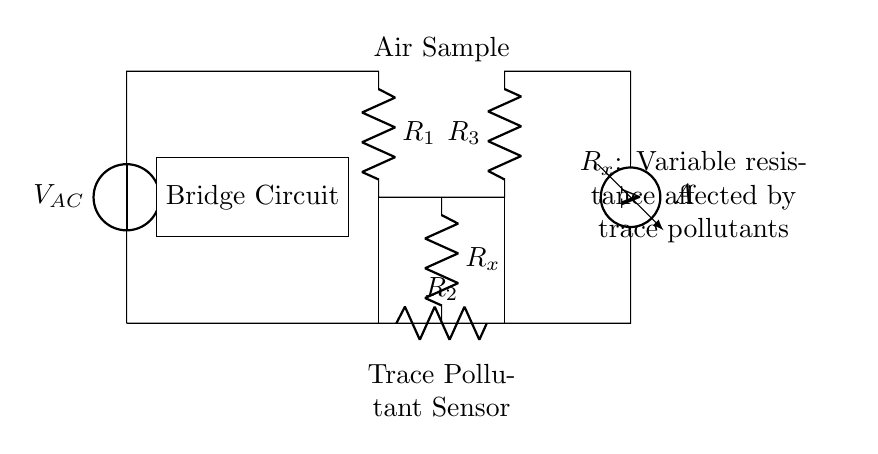What is the type of voltage source used in this circuit? The circuit uses an alternating current voltage source, indicated by the notation V_AC, which is relevant for the bridge operation designed to detect changes caused by trace pollutants.
Answer: Alternating current What component measures current in the circuit? The ammeter is the component that measures the current flowing in the circuit, which can indicate changes in current due to the presence of trace pollutants available in the air sample.
Answer: Ammeter What is the purpose of R_x in the circuit? R_x acts as a variable resistance that changes in response to the concentration of trace pollutants. This resistance is essential for balance in the bridge circuit to detect those pollutants effectively.
Answer: Trace pollutant sensor How many resistors are present in this circuit? There are four resistors labeled as R1, R2, R3, and R_x. They are part of the bridge configuration which is fundamental in the detection process of pollutants.
Answer: Four What happens when the resistance R_x changes? When R_x changes, it disrupts the balance of the bridge, leading to a measurable current in the ammeter, indicating the presence of trace pollutants. It is a principle used to sense changes in environmental conditions effectively.
Answer: Measurable current What type of circuit is depicted in this diagram? The circuit depicted is a bridge circuit, specifically designed for detecting variations in resistance caused by trace pollutants in air samples, creating sensitivity for environmental monitoring applications.
Answer: Bridge circuit 